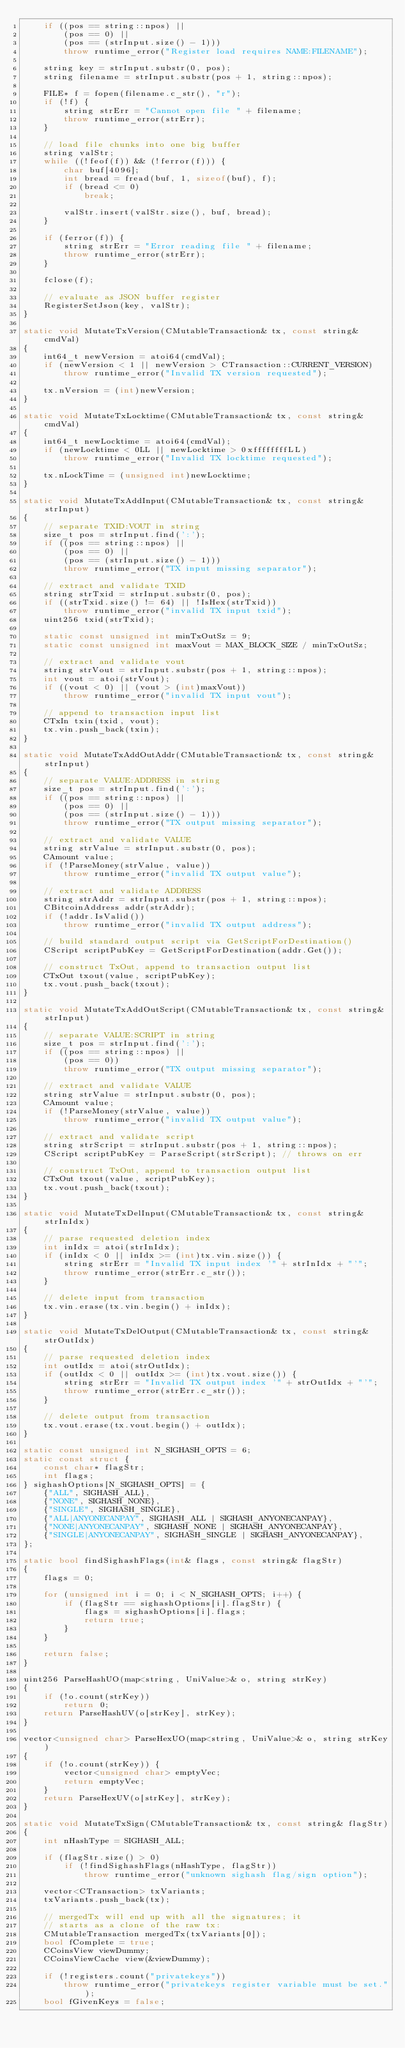<code> <loc_0><loc_0><loc_500><loc_500><_C++_>    if ((pos == string::npos) ||
        (pos == 0) ||
        (pos == (strInput.size() - 1)))
        throw runtime_error("Register load requires NAME:FILENAME");

    string key = strInput.substr(0, pos);
    string filename = strInput.substr(pos + 1, string::npos);

    FILE* f = fopen(filename.c_str(), "r");
    if (!f) {
        string strErr = "Cannot open file " + filename;
        throw runtime_error(strErr);
    }

    // load file chunks into one big buffer
    string valStr;
    while ((!feof(f)) && (!ferror(f))) {
        char buf[4096];
        int bread = fread(buf, 1, sizeof(buf), f);
        if (bread <= 0)
            break;

        valStr.insert(valStr.size(), buf, bread);
    }

    if (ferror(f)) {
        string strErr = "Error reading file " + filename;
        throw runtime_error(strErr);
    }

    fclose(f);

    // evaluate as JSON buffer register
    RegisterSetJson(key, valStr);
}

static void MutateTxVersion(CMutableTransaction& tx, const string& cmdVal)
{
    int64_t newVersion = atoi64(cmdVal);
    if (newVersion < 1 || newVersion > CTransaction::CURRENT_VERSION)
        throw runtime_error("Invalid TX version requested");

    tx.nVersion = (int)newVersion;
}

static void MutateTxLocktime(CMutableTransaction& tx, const string& cmdVal)
{
    int64_t newLocktime = atoi64(cmdVal);
    if (newLocktime < 0LL || newLocktime > 0xffffffffLL)
        throw runtime_error("Invalid TX locktime requested");

    tx.nLockTime = (unsigned int)newLocktime;
}

static void MutateTxAddInput(CMutableTransaction& tx, const string& strInput)
{
    // separate TXID:VOUT in string
    size_t pos = strInput.find(':');
    if ((pos == string::npos) ||
        (pos == 0) ||
        (pos == (strInput.size() - 1)))
        throw runtime_error("TX input missing separator");

    // extract and validate TXID
    string strTxid = strInput.substr(0, pos);
    if ((strTxid.size() != 64) || !IsHex(strTxid))
        throw runtime_error("invalid TX input txid");
    uint256 txid(strTxid);

    static const unsigned int minTxOutSz = 9;
    static const unsigned int maxVout = MAX_BLOCK_SIZE / minTxOutSz;

    // extract and validate vout
    string strVout = strInput.substr(pos + 1, string::npos);
    int vout = atoi(strVout);
    if ((vout < 0) || (vout > (int)maxVout))
        throw runtime_error("invalid TX input vout");

    // append to transaction input list
    CTxIn txin(txid, vout);
    tx.vin.push_back(txin);
}

static void MutateTxAddOutAddr(CMutableTransaction& tx, const string& strInput)
{
    // separate VALUE:ADDRESS in string
    size_t pos = strInput.find(':');
    if ((pos == string::npos) ||
        (pos == 0) ||
        (pos == (strInput.size() - 1)))
        throw runtime_error("TX output missing separator");

    // extract and validate VALUE
    string strValue = strInput.substr(0, pos);
    CAmount value;
    if (!ParseMoney(strValue, value))
        throw runtime_error("invalid TX output value");

    // extract and validate ADDRESS
    string strAddr = strInput.substr(pos + 1, string::npos);
    CBitcoinAddress addr(strAddr);
    if (!addr.IsValid())
        throw runtime_error("invalid TX output address");

    // build standard output script via GetScriptForDestination()
    CScript scriptPubKey = GetScriptForDestination(addr.Get());

    // construct TxOut, append to transaction output list
    CTxOut txout(value, scriptPubKey);
    tx.vout.push_back(txout);
}

static void MutateTxAddOutScript(CMutableTransaction& tx, const string& strInput)
{
    // separate VALUE:SCRIPT in string
    size_t pos = strInput.find(':');
    if ((pos == string::npos) ||
        (pos == 0))
        throw runtime_error("TX output missing separator");

    // extract and validate VALUE
    string strValue = strInput.substr(0, pos);
    CAmount value;
    if (!ParseMoney(strValue, value))
        throw runtime_error("invalid TX output value");

    // extract and validate script
    string strScript = strInput.substr(pos + 1, string::npos);
    CScript scriptPubKey = ParseScript(strScript); // throws on err

    // construct TxOut, append to transaction output list
    CTxOut txout(value, scriptPubKey);
    tx.vout.push_back(txout);
}

static void MutateTxDelInput(CMutableTransaction& tx, const string& strInIdx)
{
    // parse requested deletion index
    int inIdx = atoi(strInIdx);
    if (inIdx < 0 || inIdx >= (int)tx.vin.size()) {
        string strErr = "Invalid TX input index '" + strInIdx + "'";
        throw runtime_error(strErr.c_str());
    }

    // delete input from transaction
    tx.vin.erase(tx.vin.begin() + inIdx);
}

static void MutateTxDelOutput(CMutableTransaction& tx, const string& strOutIdx)
{
    // parse requested deletion index
    int outIdx = atoi(strOutIdx);
    if (outIdx < 0 || outIdx >= (int)tx.vout.size()) {
        string strErr = "Invalid TX output index '" + strOutIdx + "'";
        throw runtime_error(strErr.c_str());
    }

    // delete output from transaction
    tx.vout.erase(tx.vout.begin() + outIdx);
}

static const unsigned int N_SIGHASH_OPTS = 6;
static const struct {
    const char* flagStr;
    int flags;
} sighashOptions[N_SIGHASH_OPTS] = {
    {"ALL", SIGHASH_ALL},
    {"NONE", SIGHASH_NONE},
    {"SINGLE", SIGHASH_SINGLE},
    {"ALL|ANYONECANPAY", SIGHASH_ALL | SIGHASH_ANYONECANPAY},
    {"NONE|ANYONECANPAY", SIGHASH_NONE | SIGHASH_ANYONECANPAY},
    {"SINGLE|ANYONECANPAY", SIGHASH_SINGLE | SIGHASH_ANYONECANPAY},
};

static bool findSighashFlags(int& flags, const string& flagStr)
{
    flags = 0;

    for (unsigned int i = 0; i < N_SIGHASH_OPTS; i++) {
        if (flagStr == sighashOptions[i].flagStr) {
            flags = sighashOptions[i].flags;
            return true;
        }
    }

    return false;
}

uint256 ParseHashUO(map<string, UniValue>& o, string strKey)
{
    if (!o.count(strKey))
        return 0;
    return ParseHashUV(o[strKey], strKey);
}

vector<unsigned char> ParseHexUO(map<string, UniValue>& o, string strKey)
{
    if (!o.count(strKey)) {
        vector<unsigned char> emptyVec;
        return emptyVec;
    }
    return ParseHexUV(o[strKey], strKey);
}

static void MutateTxSign(CMutableTransaction& tx, const string& flagStr)
{
    int nHashType = SIGHASH_ALL;

    if (flagStr.size() > 0)
        if (!findSighashFlags(nHashType, flagStr))
            throw runtime_error("unknown sighash flag/sign option");

    vector<CTransaction> txVariants;
    txVariants.push_back(tx);

    // mergedTx will end up with all the signatures; it
    // starts as a clone of the raw tx:
    CMutableTransaction mergedTx(txVariants[0]);
    bool fComplete = true;
    CCoinsView viewDummy;
    CCoinsViewCache view(&viewDummy);

    if (!registers.count("privatekeys"))
        throw runtime_error("privatekeys register variable must be set.");
    bool fGivenKeys = false;</code> 